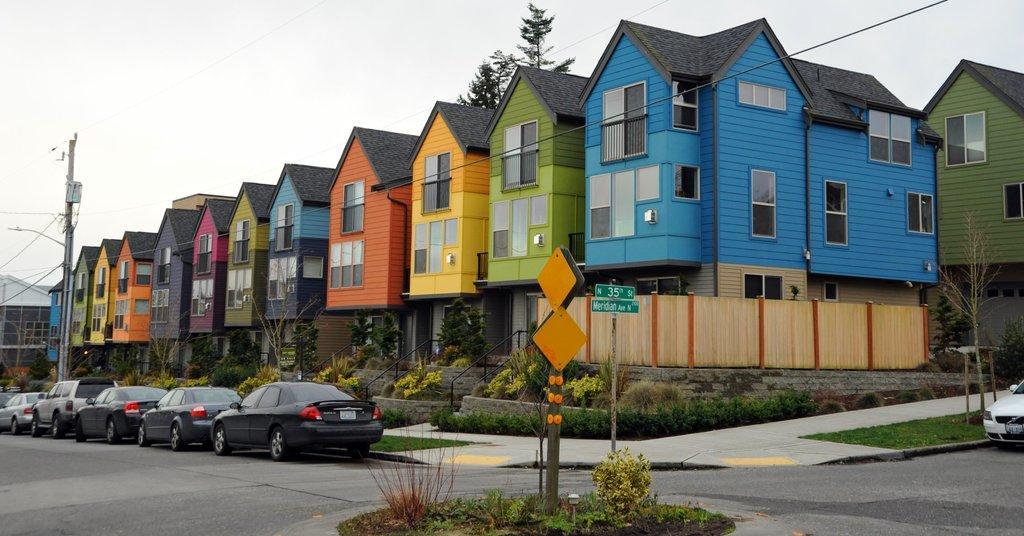Please provide a concise description of this image. In this picture I can observe different colors of building in the middle of the picture. In front of the buildings there are plants and some cars parked on the side of the road. In the background I can observe sky. 